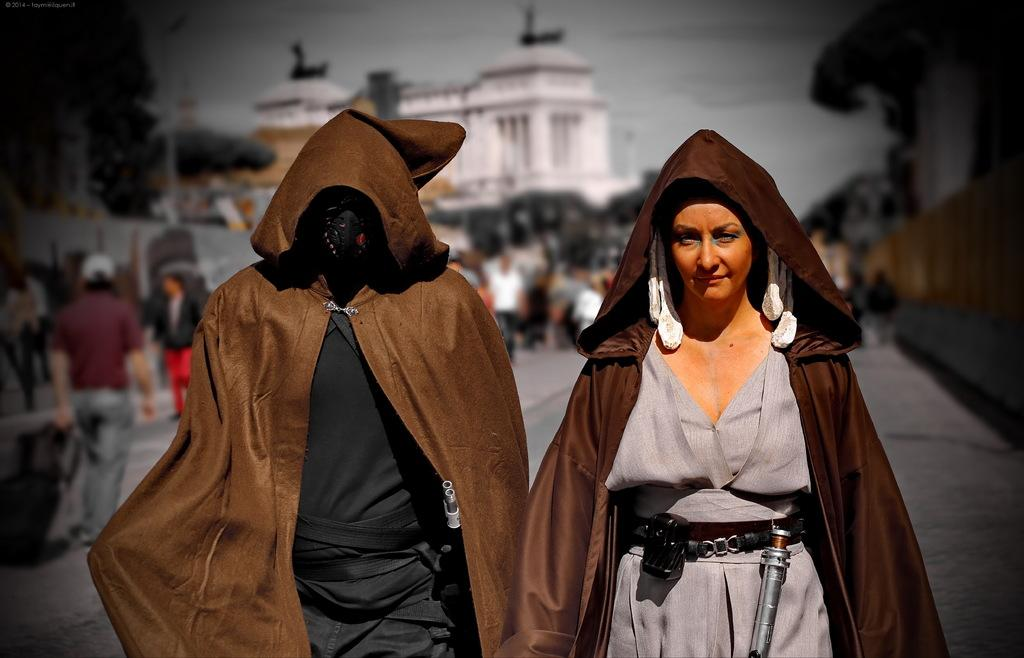How many people can be seen in the image? There are people in the image, but the exact number cannot be determined from the provided facts. What is the surface that the people are standing on? The ground is visible in the image, which is likely the surface the people are standing on. What type of structures are present in the image? There are buildings in the image. What type of vegetation is present in the image? Trees are present in the image. What are the poles used for in the image? The purpose of the poles cannot be determined from the provided facts. What is visible in the sky in the image? The sky is visible in the image, but the weather or any specific features cannot be determined. How many cars are parked near the swing in the image? There is no swing or cars present in the image. 